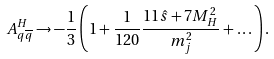Convert formula to latex. <formula><loc_0><loc_0><loc_500><loc_500>A _ { q \overline { q } } ^ { H } \rightarrow - \frac { 1 } { 3 } \left ( 1 + \frac { 1 } { 1 2 0 } \frac { 1 1 \hat { s } + 7 M _ { H } ^ { 2 } } { m _ { j } ^ { 2 } } + \dots \right ) .</formula> 